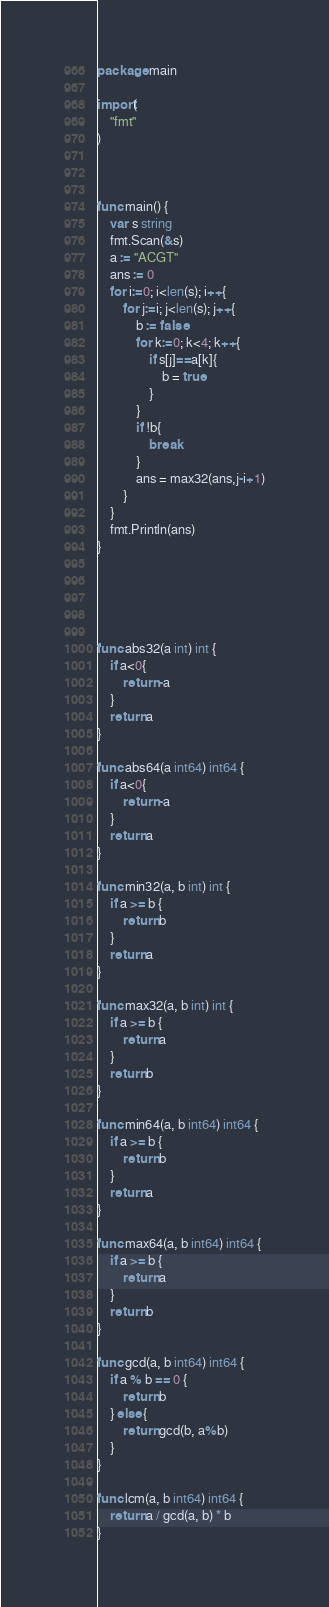<code> <loc_0><loc_0><loc_500><loc_500><_Go_>package main

import(
    "fmt"
)



func main() {
    var s string
    fmt.Scan(&s)
    a := "ACGT"
    ans := 0
    for i:=0; i<len(s); i++{
        for j:=i; j<len(s); j++{
            b := false
            for k:=0; k<4; k++{
                if s[j]==a[k]{
                    b = true
                }
            }
            if !b{
                break
            }
            ans = max32(ans,j-i+1)
        }
    }
    fmt.Println(ans)
}





func abs32(a int) int {
    if a<0{
        return -a
    }
    return a
}

func abs64(a int64) int64 {
    if a<0{
        return -a
    }
    return a
}

func min32(a, b int) int {
    if a >= b {
        return b
    }
    return a
}

func max32(a, b int) int {
    if a >= b {
        return a
    }
    return b
}

func min64(a, b int64) int64 {
    if a >= b {
        return b
    }
    return a
}

func max64(a, b int64) int64 {
    if a >= b {
        return a
    }
    return b
}

func gcd(a, b int64) int64 {
    if a % b == 0 {
        return b
    } else {
        return gcd(b, a%b)
    }
}

func lcm(a, b int64) int64 {
    return a / gcd(a, b) * b
}
</code> 